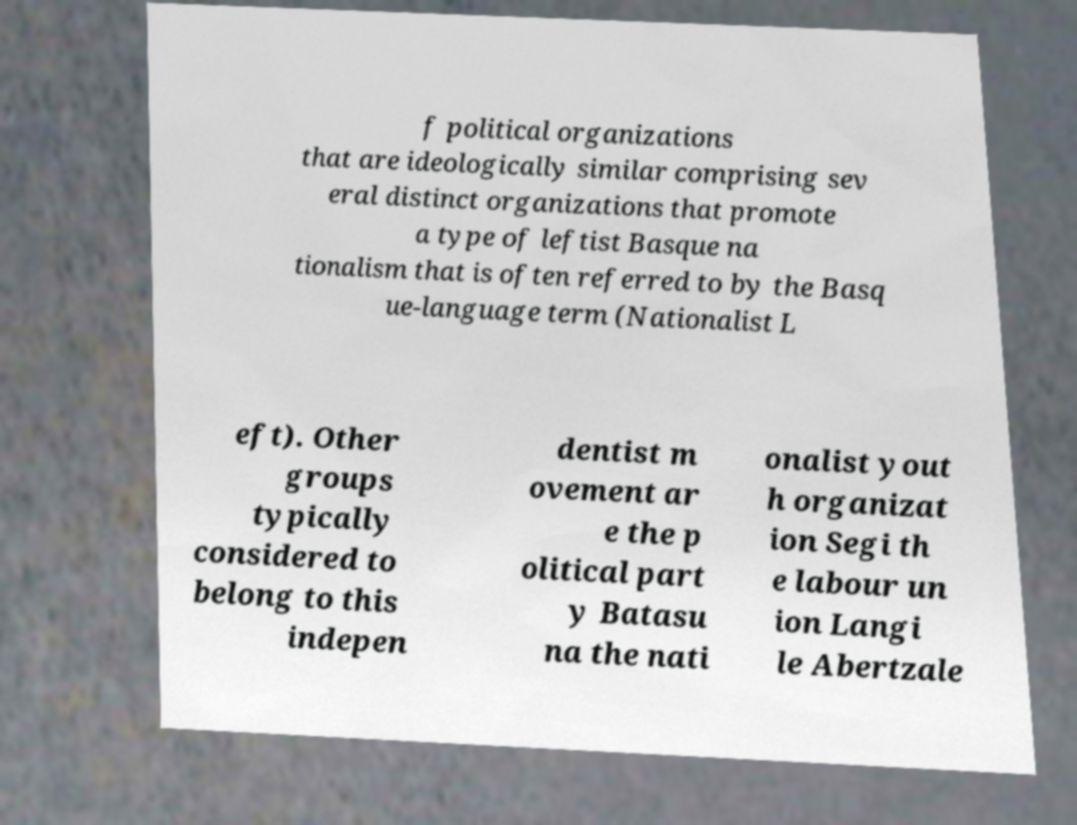Please identify and transcribe the text found in this image. f political organizations that are ideologically similar comprising sev eral distinct organizations that promote a type of leftist Basque na tionalism that is often referred to by the Basq ue-language term (Nationalist L eft). Other groups typically considered to belong to this indepen dentist m ovement ar e the p olitical part y Batasu na the nati onalist yout h organizat ion Segi th e labour un ion Langi le Abertzale 